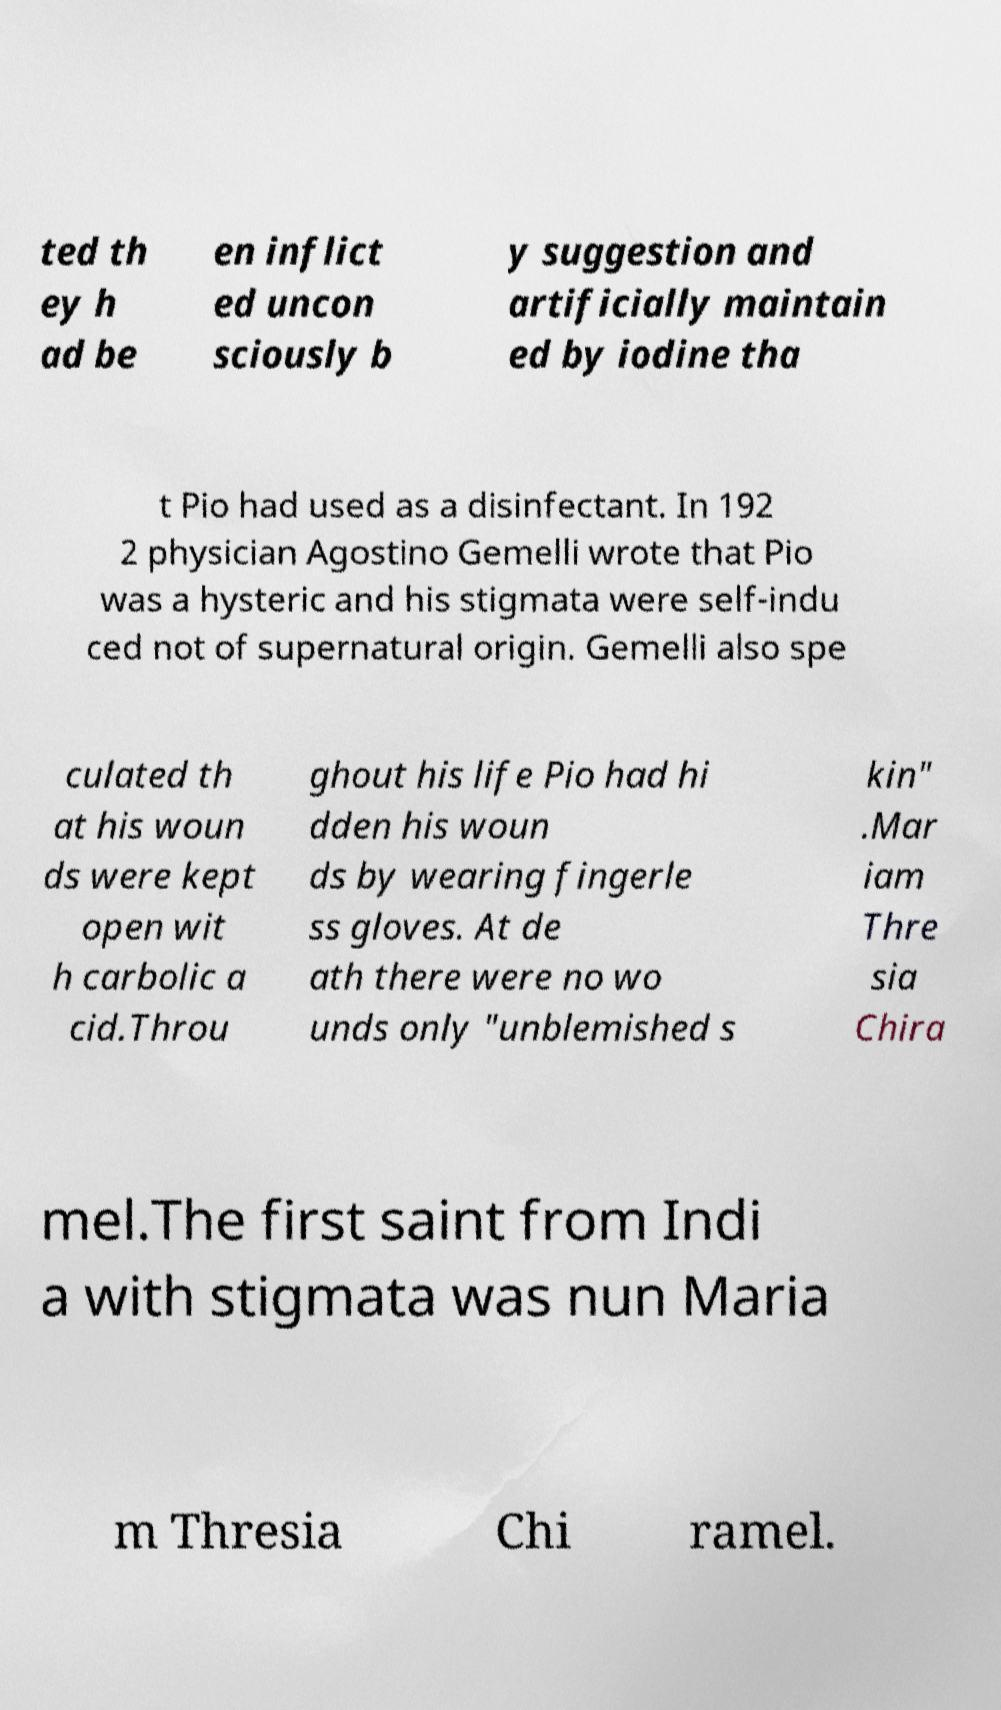Please read and relay the text visible in this image. What does it say? ted th ey h ad be en inflict ed uncon sciously b y suggestion and artificially maintain ed by iodine tha t Pio had used as a disinfectant. In 192 2 physician Agostino Gemelli wrote that Pio was a hysteric and his stigmata were self-indu ced not of supernatural origin. Gemelli also spe culated th at his woun ds were kept open wit h carbolic a cid.Throu ghout his life Pio had hi dden his woun ds by wearing fingerle ss gloves. At de ath there were no wo unds only "unblemished s kin" .Mar iam Thre sia Chira mel.The first saint from Indi a with stigmata was nun Maria m Thresia Chi ramel. 